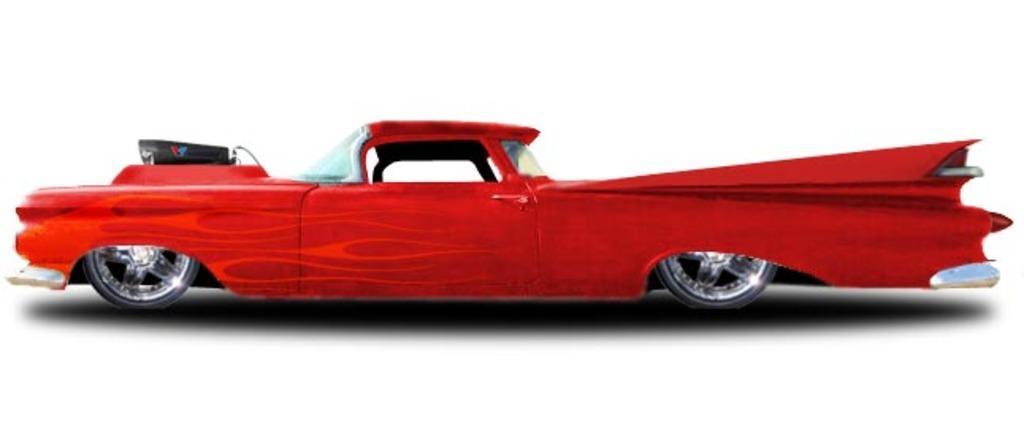In one or two sentences, can you explain what this image depicts? This picture shows that there is a red color car. 